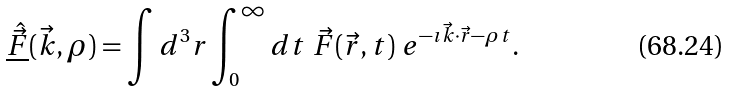Convert formula to latex. <formula><loc_0><loc_0><loc_500><loc_500>\underline { \hat { \vec { F } } } ( \vec { k } , \rho ) = \int d ^ { 3 } r \int _ { 0 } ^ { \infty } d t \ \vec { F } ( \vec { r } , t ) \ e ^ { - \imath \vec { k } \cdot \vec { r } - \rho t } .</formula> 